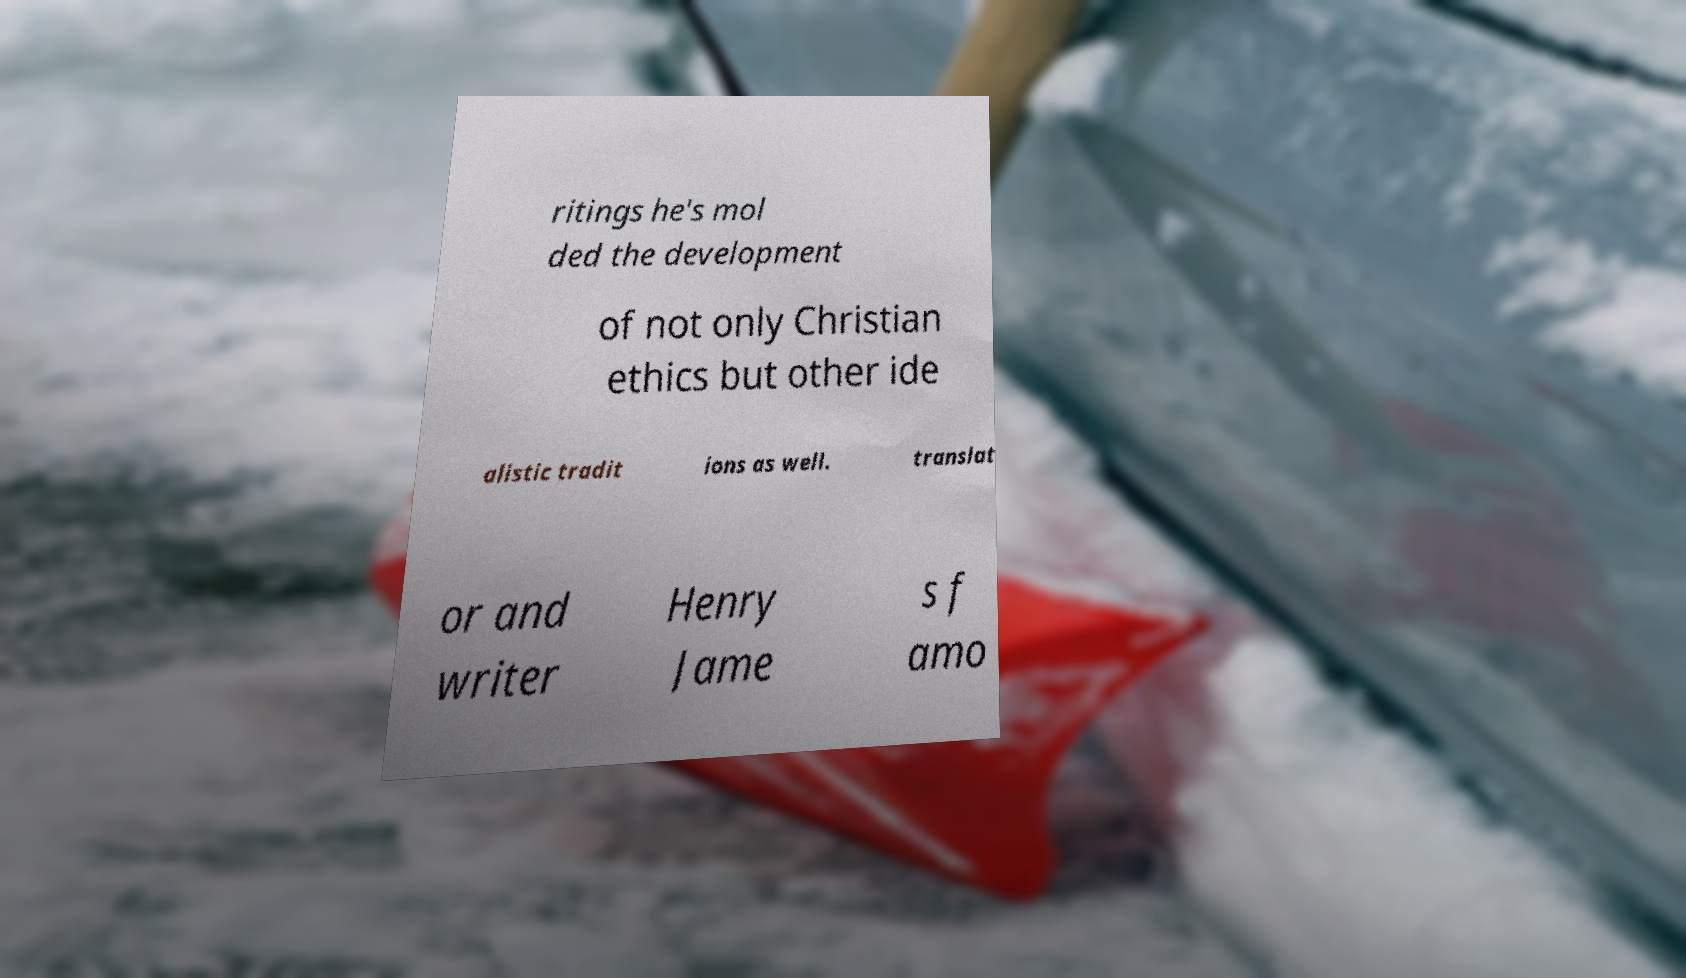There's text embedded in this image that I need extracted. Can you transcribe it verbatim? ritings he's mol ded the development of not only Christian ethics but other ide alistic tradit ions as well. translat or and writer Henry Jame s f amo 